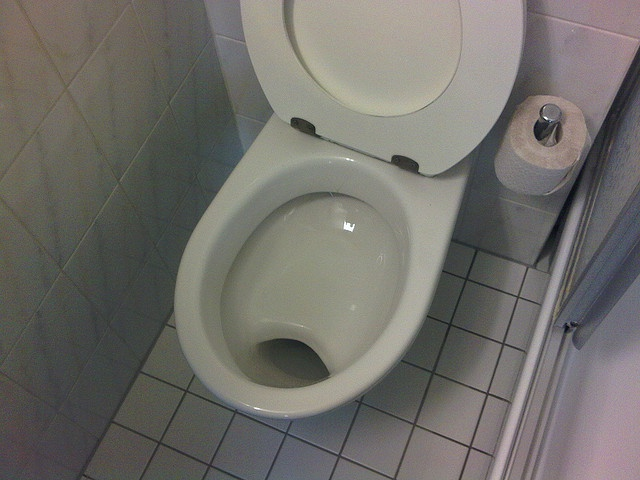Describe the objects in this image and their specific colors. I can see a toilet in gray, darkgray, and black tones in this image. 